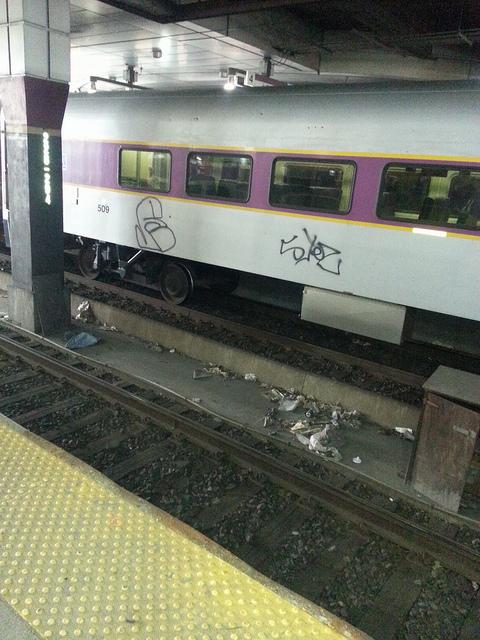What color is around the train windows?
Concise answer only. Purple. Is there graffiti on the train?
Be succinct. Yes. Where was the picture taken of the train?
Concise answer only. Station. 